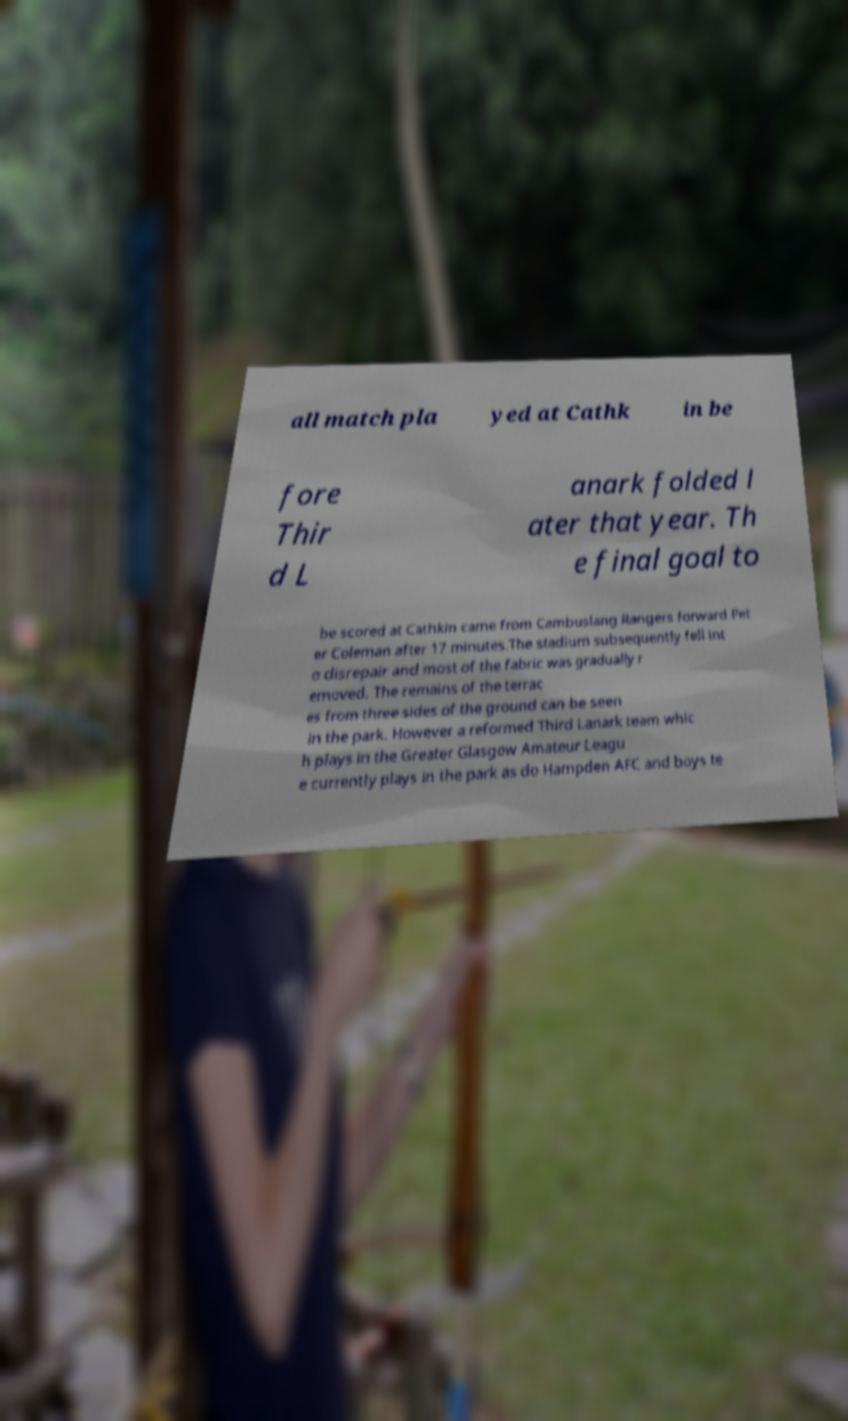Please read and relay the text visible in this image. What does it say? all match pla yed at Cathk in be fore Thir d L anark folded l ater that year. Th e final goal to be scored at Cathkin came from Cambuslang Rangers forward Pet er Coleman after 17 minutes.The stadium subsequently fell int o disrepair and most of the fabric was gradually r emoved. The remains of the terrac es from three sides of the ground can be seen in the park. However a reformed Third Lanark team whic h plays in the Greater Glasgow Amateur Leagu e currently plays in the park as do Hampden AFC and boys te 